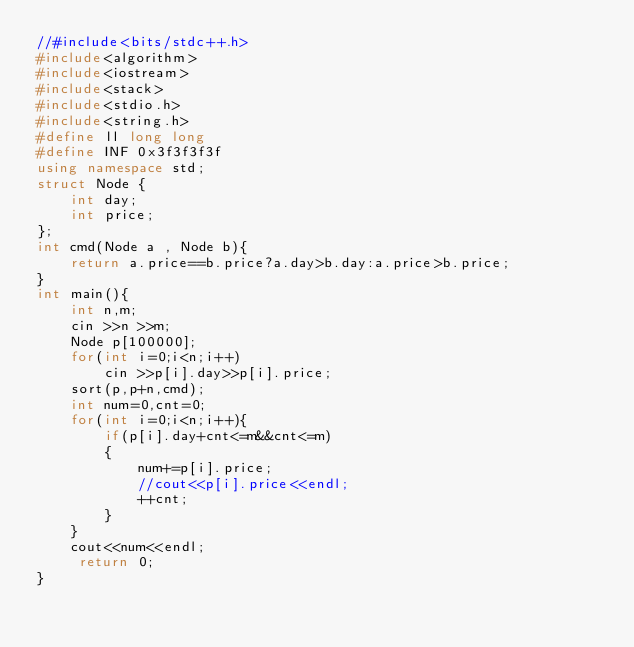Convert code to text. <code><loc_0><loc_0><loc_500><loc_500><_C++_>//#include<bits/stdc++.h>
#include<algorithm>
#include<iostream>
#include<stack>
#include<stdio.h>
#include<string.h>
#define ll long long
#define INF 0x3f3f3f3f
using namespace std;
struct Node {
    int day;
    int price;
};
int cmd(Node a , Node b){
    return a.price==b.price?a.day>b.day:a.price>b.price;
}
int main(){
    int n,m;
    cin >>n >>m;
    Node p[100000];
    for(int i=0;i<n;i++)
        cin >>p[i].day>>p[i].price;
    sort(p,p+n,cmd);
    int num=0,cnt=0;
    for(int i=0;i<n;i++){
        if(p[i].day+cnt<=m&&cnt<=m)
        {
            num+=p[i].price;
            //cout<<p[i].price<<endl;
            ++cnt;
        }
    }
    cout<<num<<endl;
     return 0;
}
</code> 